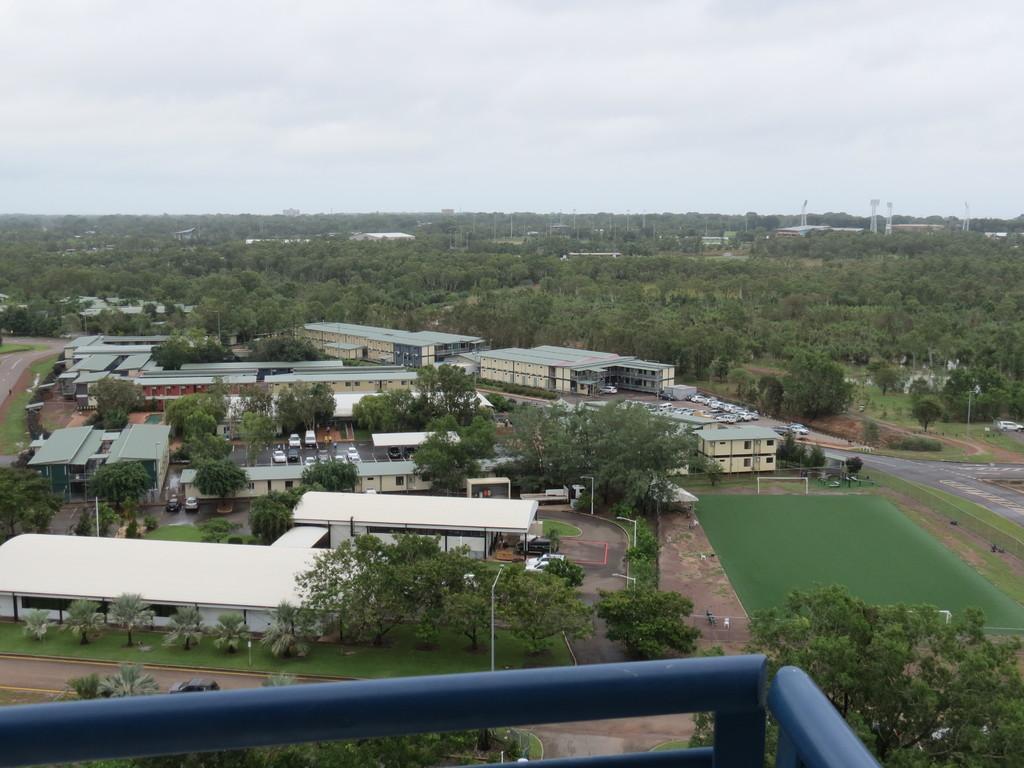Please provide a concise description of this image. In this image we can see buildings, trees, towers and cars on the road. On the right side of the image there is a volleyball court. In the background there is the sky. 